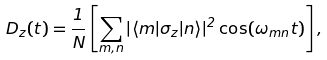Convert formula to latex. <formula><loc_0><loc_0><loc_500><loc_500>D _ { z } ( t ) = \frac { 1 } { N } \left [ \sum _ { m , n } | \langle m | \sigma _ { z } | n \rangle | ^ { 2 } \cos ( \omega _ { m n } t ) \right ] ,</formula> 